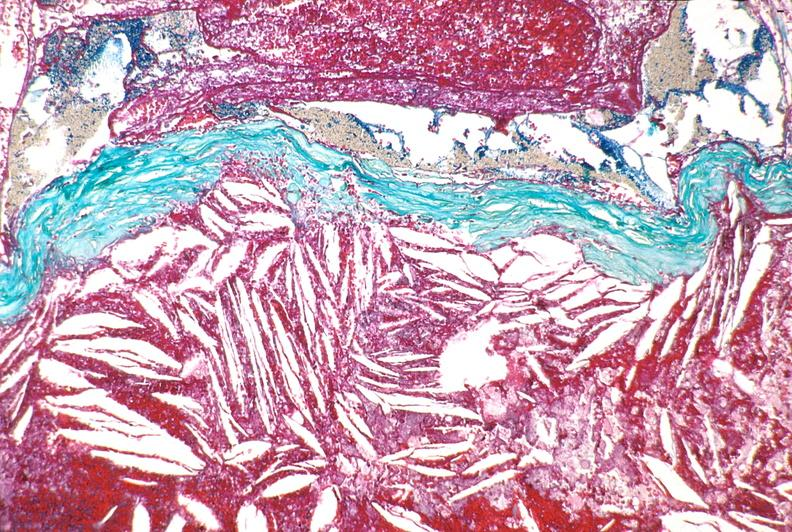s aldehyde fuscin present?
Answer the question using a single word or phrase. No 